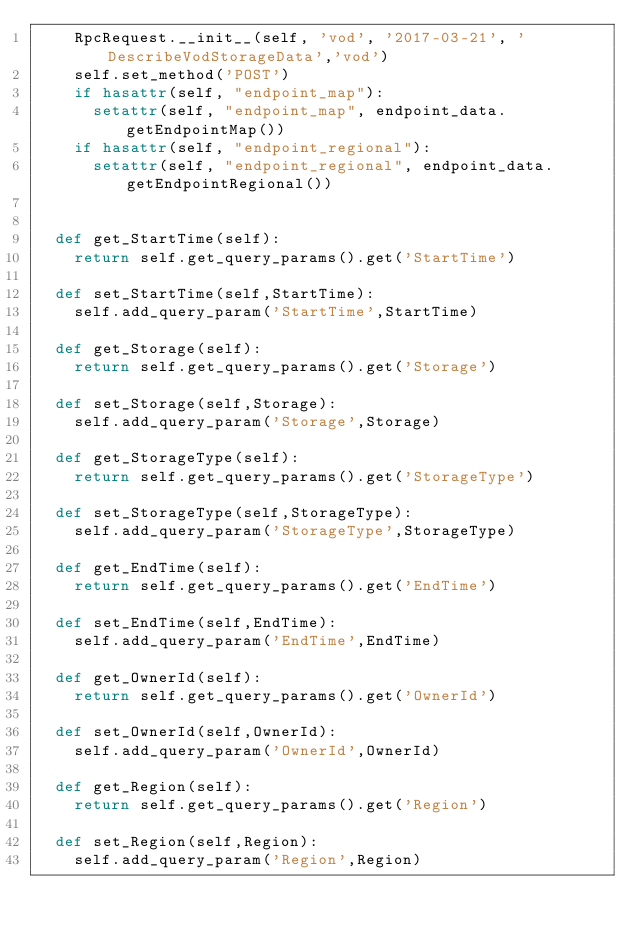<code> <loc_0><loc_0><loc_500><loc_500><_Python_>		RpcRequest.__init__(self, 'vod', '2017-03-21', 'DescribeVodStorageData','vod')
		self.set_method('POST')
		if hasattr(self, "endpoint_map"):
			setattr(self, "endpoint_map", endpoint_data.getEndpointMap())
		if hasattr(self, "endpoint_regional"):
			setattr(self, "endpoint_regional", endpoint_data.getEndpointRegional())


	def get_StartTime(self):
		return self.get_query_params().get('StartTime')

	def set_StartTime(self,StartTime):
		self.add_query_param('StartTime',StartTime)

	def get_Storage(self):
		return self.get_query_params().get('Storage')

	def set_Storage(self,Storage):
		self.add_query_param('Storage',Storage)

	def get_StorageType(self):
		return self.get_query_params().get('StorageType')

	def set_StorageType(self,StorageType):
		self.add_query_param('StorageType',StorageType)

	def get_EndTime(self):
		return self.get_query_params().get('EndTime')

	def set_EndTime(self,EndTime):
		self.add_query_param('EndTime',EndTime)

	def get_OwnerId(self):
		return self.get_query_params().get('OwnerId')

	def set_OwnerId(self,OwnerId):
		self.add_query_param('OwnerId',OwnerId)

	def get_Region(self):
		return self.get_query_params().get('Region')

	def set_Region(self,Region):
		self.add_query_param('Region',Region)</code> 